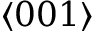Convert formula to latex. <formula><loc_0><loc_0><loc_500><loc_500>\langle 0 0 1 \rangle</formula> 